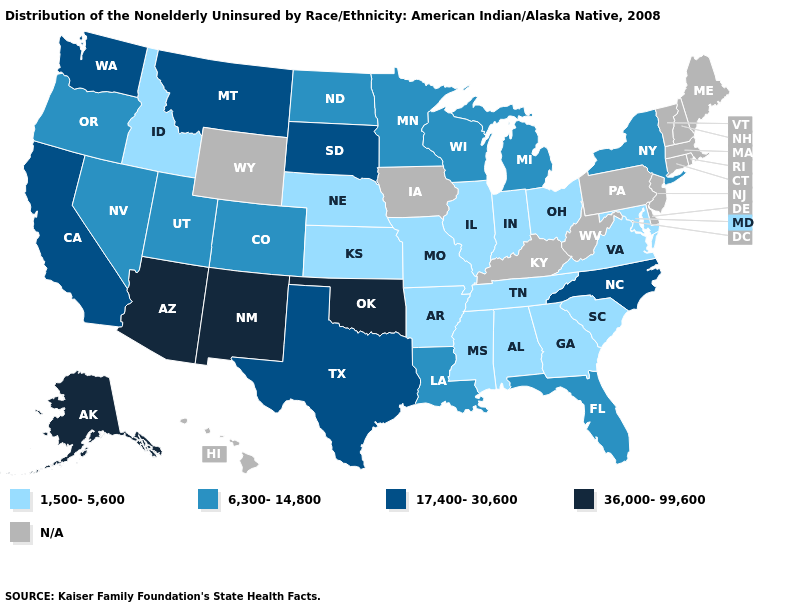Among the states that border New Jersey , which have the lowest value?
Quick response, please. New York. Which states have the lowest value in the USA?
Be succinct. Alabama, Arkansas, Georgia, Idaho, Illinois, Indiana, Kansas, Maryland, Mississippi, Missouri, Nebraska, Ohio, South Carolina, Tennessee, Virginia. Name the states that have a value in the range 17,400-30,600?
Be succinct. California, Montana, North Carolina, South Dakota, Texas, Washington. Name the states that have a value in the range 17,400-30,600?
Concise answer only. California, Montana, North Carolina, South Dakota, Texas, Washington. What is the highest value in the South ?
Keep it brief. 36,000-99,600. Among the states that border Kansas , does Oklahoma have the lowest value?
Write a very short answer. No. What is the lowest value in the USA?
Be succinct. 1,500-5,600. What is the lowest value in states that border Oklahoma?
Concise answer only. 1,500-5,600. Name the states that have a value in the range 1,500-5,600?
Keep it brief. Alabama, Arkansas, Georgia, Idaho, Illinois, Indiana, Kansas, Maryland, Mississippi, Missouri, Nebraska, Ohio, South Carolina, Tennessee, Virginia. Does the first symbol in the legend represent the smallest category?
Answer briefly. Yes. What is the highest value in states that border Washington?
Short answer required. 6,300-14,800. What is the value of Washington?
Write a very short answer. 17,400-30,600. How many symbols are there in the legend?
Concise answer only. 5. What is the lowest value in the USA?
Keep it brief. 1,500-5,600. 